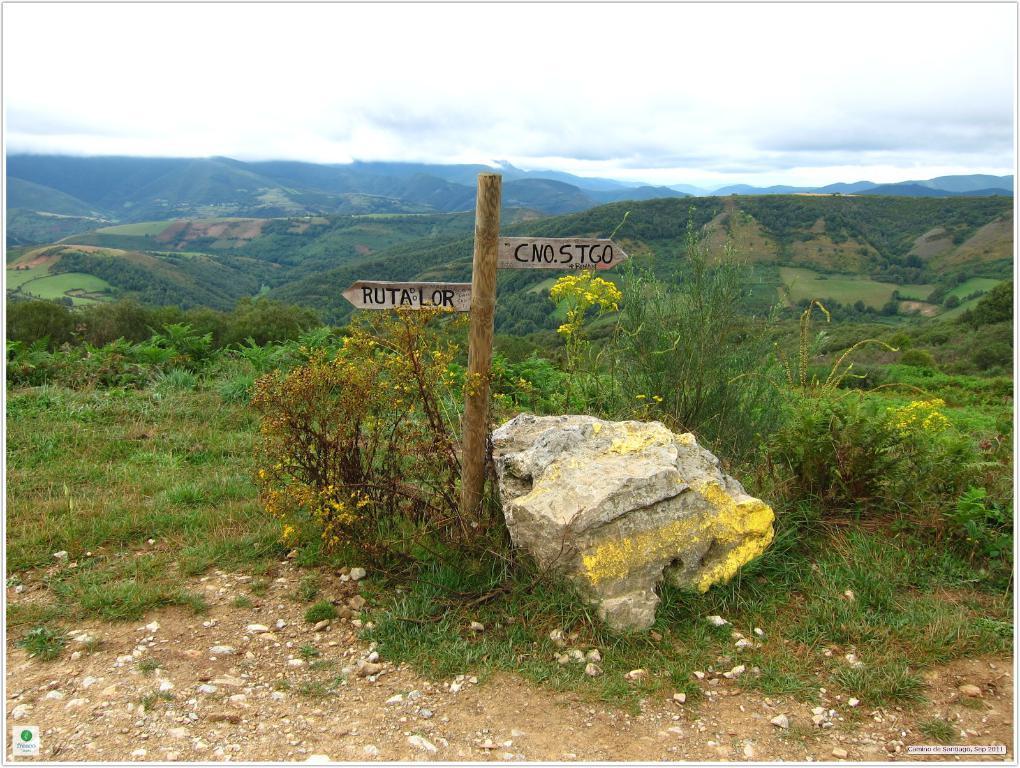How would you summarize this image in a sentence or two? In this picture there are boards on the pole and there is text on the boards and there is a rock. At the back there are trees on the mountains. At the top there is sky and there are clouds. At the bottom there is mud and there are stones and there is grass. 